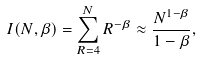Convert formula to latex. <formula><loc_0><loc_0><loc_500><loc_500>I ( N , \beta ) = \sum _ { R = 4 } ^ { N } R ^ { - \beta } \approx \frac { N ^ { 1 - \beta } } { 1 - \beta } ,</formula> 